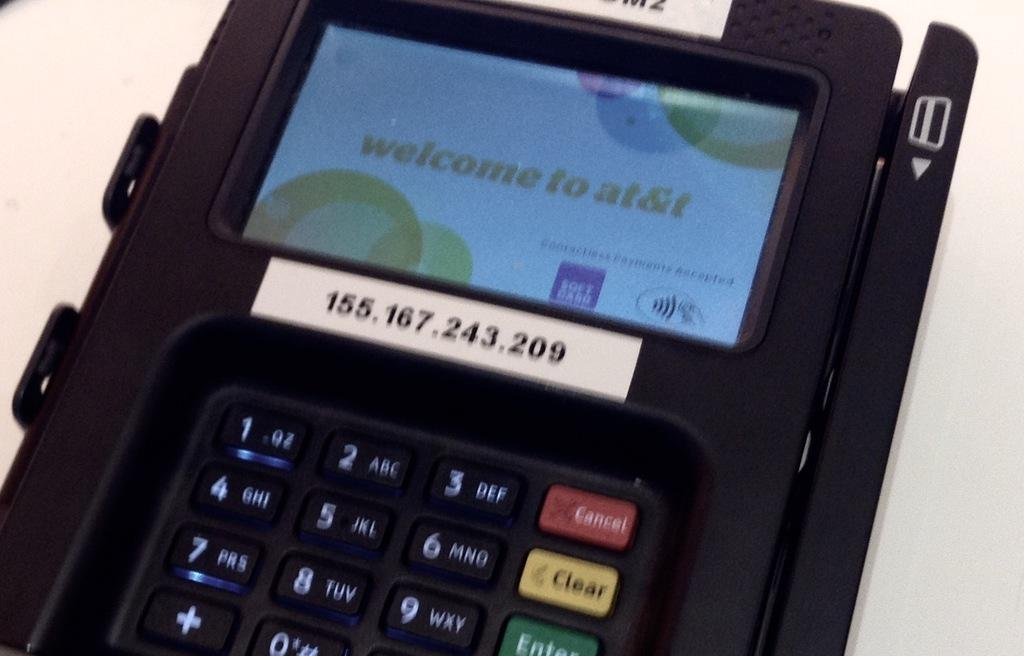<image>
Present a compact description of the photo's key features. Claculator with a screen that says Welcome to At&t. 